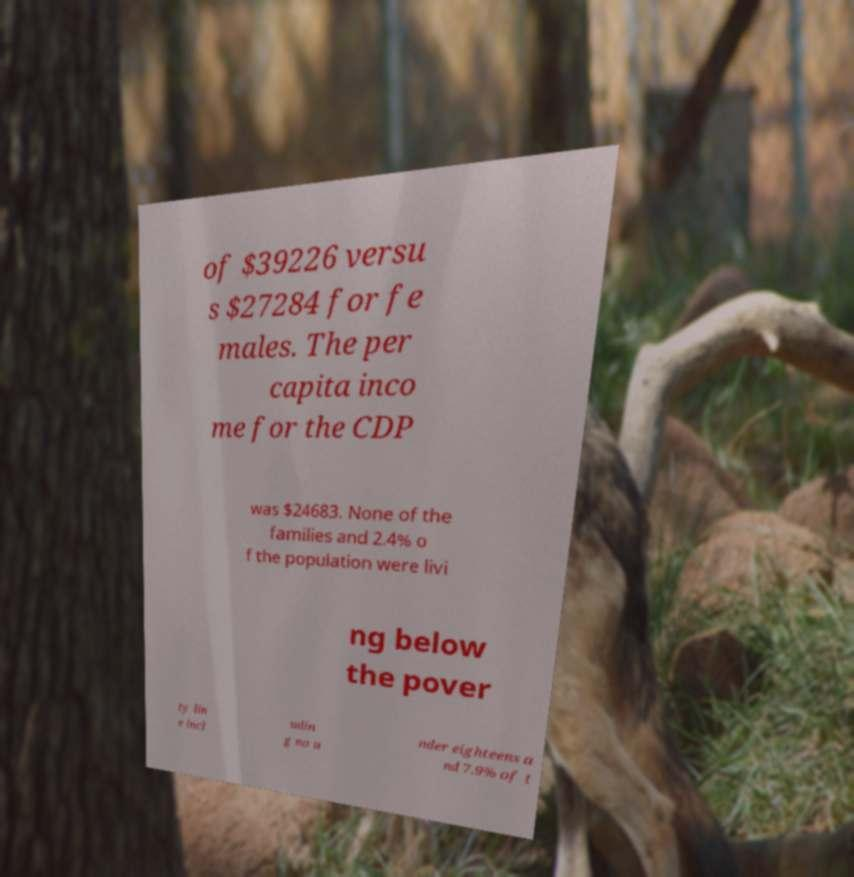Please read and relay the text visible in this image. What does it say? of $39226 versu s $27284 for fe males. The per capita inco me for the CDP was $24683. None of the families and 2.4% o f the population were livi ng below the pover ty lin e incl udin g no u nder eighteens a nd 7.9% of t 